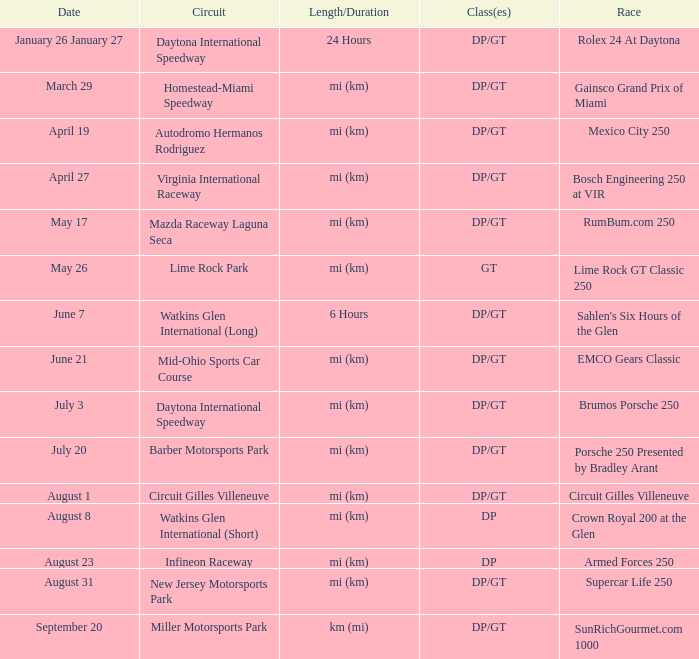What was the date of the race that lasted 6 hours? June 7. Could you help me parse every detail presented in this table? {'header': ['Date', 'Circuit', 'Length/Duration', 'Class(es)', 'Race'], 'rows': [['January 26 January 27', 'Daytona International Speedway', '24 Hours', 'DP/GT', 'Rolex 24 At Daytona'], ['March 29', 'Homestead-Miami Speedway', 'mi (km)', 'DP/GT', 'Gainsco Grand Prix of Miami'], ['April 19', 'Autodromo Hermanos Rodriguez', 'mi (km)', 'DP/GT', 'Mexico City 250'], ['April 27', 'Virginia International Raceway', 'mi (km)', 'DP/GT', 'Bosch Engineering 250 at VIR'], ['May 17', 'Mazda Raceway Laguna Seca', 'mi (km)', 'DP/GT', 'RumBum.com 250'], ['May 26', 'Lime Rock Park', 'mi (km)', 'GT', 'Lime Rock GT Classic 250'], ['June 7', 'Watkins Glen International (Long)', '6 Hours', 'DP/GT', "Sahlen's Six Hours of the Glen"], ['June 21', 'Mid-Ohio Sports Car Course', 'mi (km)', 'DP/GT', 'EMCO Gears Classic'], ['July 3', 'Daytona International Speedway', 'mi (km)', 'DP/GT', 'Brumos Porsche 250'], ['July 20', 'Barber Motorsports Park', 'mi (km)', 'DP/GT', 'Porsche 250 Presented by Bradley Arant'], ['August 1', 'Circuit Gilles Villeneuve', 'mi (km)', 'DP/GT', 'Circuit Gilles Villeneuve'], ['August 8', 'Watkins Glen International (Short)', 'mi (km)', 'DP', 'Crown Royal 200 at the Glen'], ['August 23', 'Infineon Raceway', 'mi (km)', 'DP', 'Armed Forces 250'], ['August 31', 'New Jersey Motorsports Park', 'mi (km)', 'DP/GT', 'Supercar Life 250'], ['September 20', 'Miller Motorsports Park', 'km (mi)', 'DP/GT', 'SunRichGourmet.com 1000']]} 